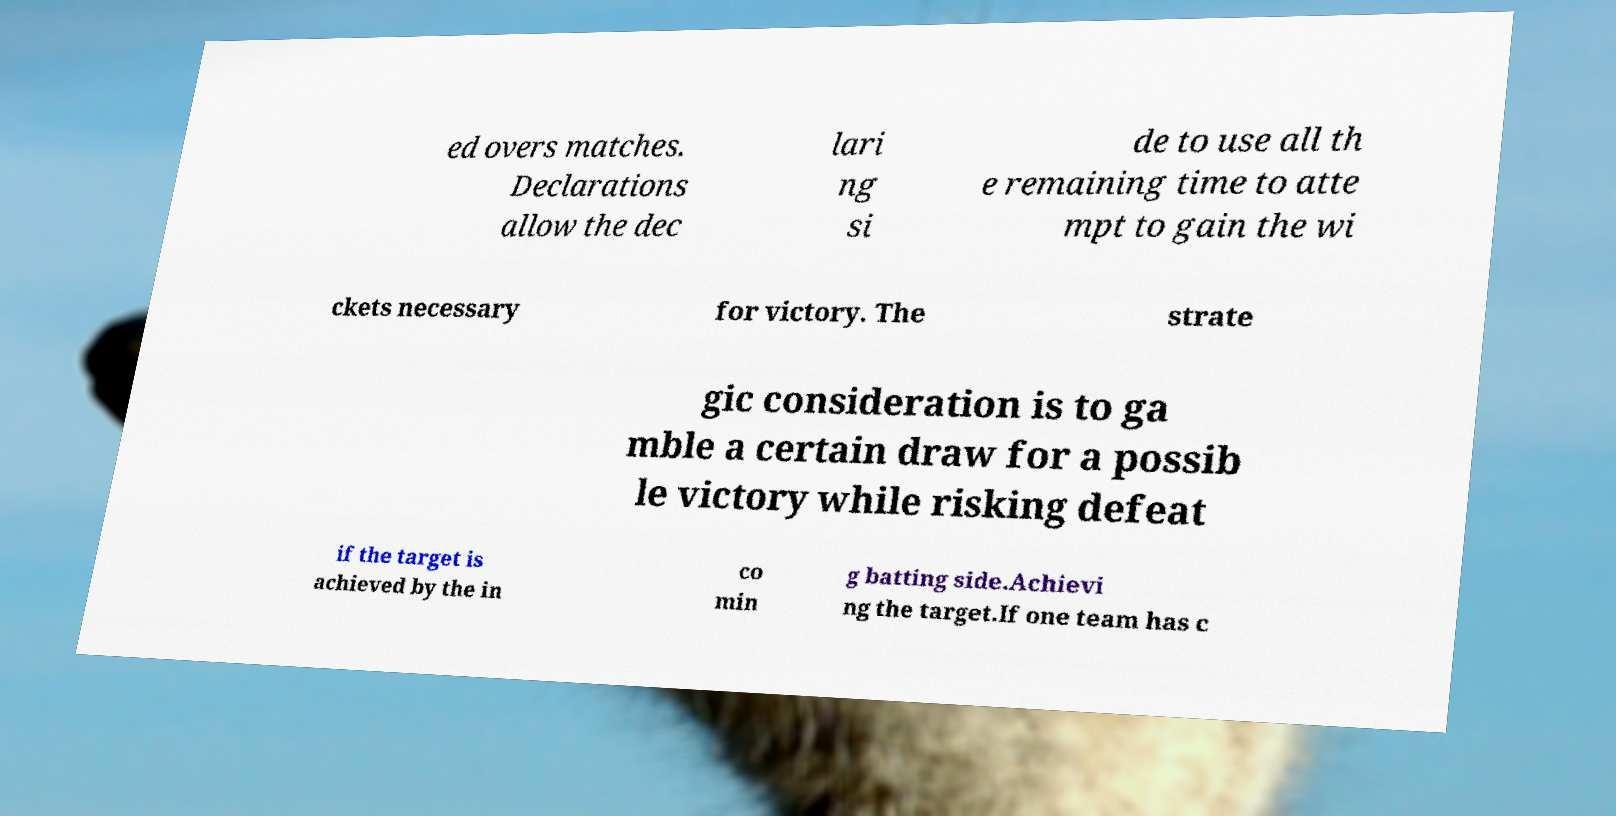What messages or text are displayed in this image? I need them in a readable, typed format. ed overs matches. Declarations allow the dec lari ng si de to use all th e remaining time to atte mpt to gain the wi ckets necessary for victory. The strate gic consideration is to ga mble a certain draw for a possib le victory while risking defeat if the target is achieved by the in co min g batting side.Achievi ng the target.If one team has c 